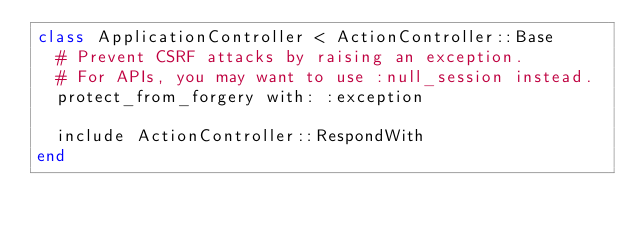Convert code to text. <code><loc_0><loc_0><loc_500><loc_500><_Ruby_>class ApplicationController < ActionController::Base
  # Prevent CSRF attacks by raising an exception.
  # For APIs, you may want to use :null_session instead.
  protect_from_forgery with: :exception

  include ActionController::RespondWith
end
</code> 